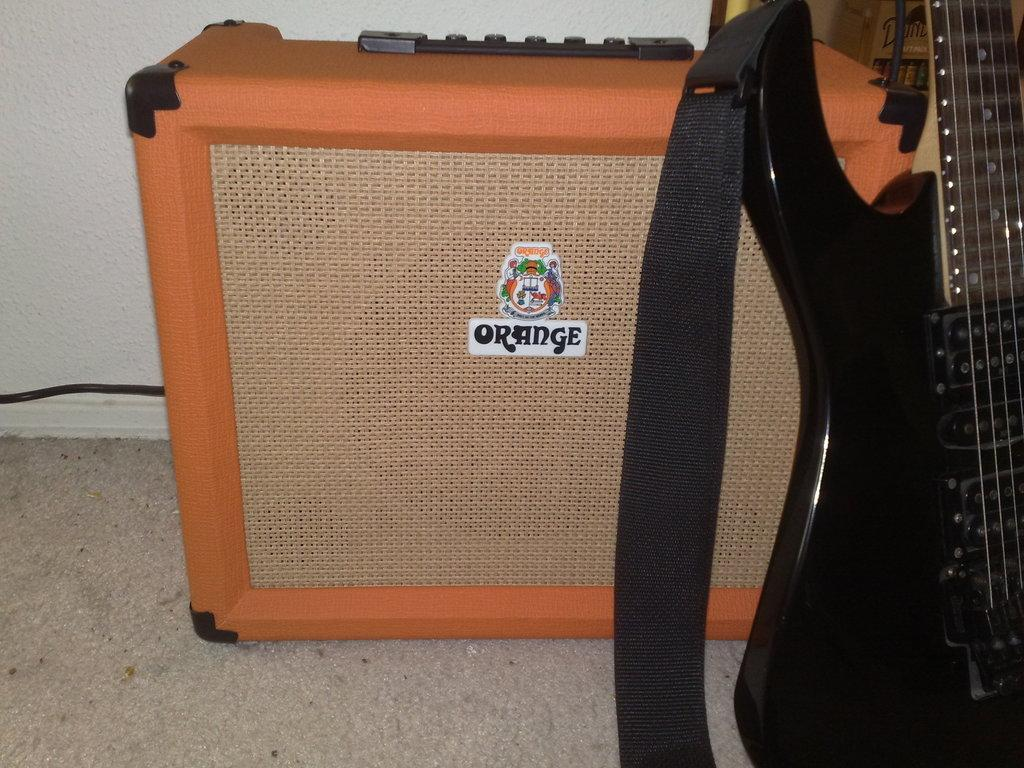What type of structure can be seen in the picture? There is a wall in the picture. What is the surface beneath the objects in the image? There is a floor in the picture. What is the color of the box on the floor? The box on the floor is orange-colored. What musical instrument is beside the box? There is a guitar beside the box. What accessory is near the guitar? There is a belt near the guitar. What type of collar can be seen on the guitar in the image? There is no collar present on the guitar in the image. Is there a book visible in the image? There is no book present in the image. 